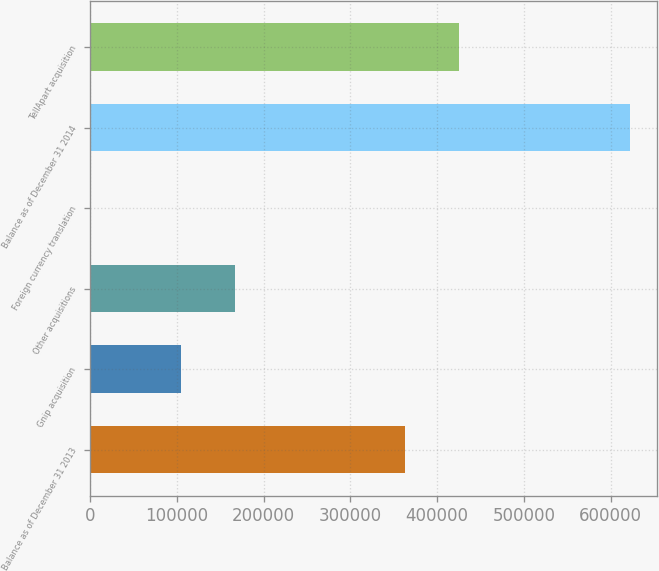<chart> <loc_0><loc_0><loc_500><loc_500><bar_chart><fcel>Balance as of December 31 2013<fcel>Gnip acquisition<fcel>Other acquisitions<fcel>Foreign currency translation<fcel>Balance as of December 31 2014<fcel>TellApart acquisition<nl><fcel>363477<fcel>104747<fcel>166933<fcel>708<fcel>622570<fcel>425663<nl></chart> 